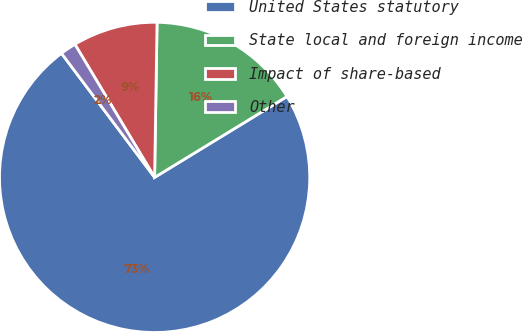<chart> <loc_0><loc_0><loc_500><loc_500><pie_chart><fcel>United States statutory<fcel>State local and foreign income<fcel>Impact of share-based<fcel>Other<nl><fcel>73.48%<fcel>16.02%<fcel>8.84%<fcel>1.66%<nl></chart> 